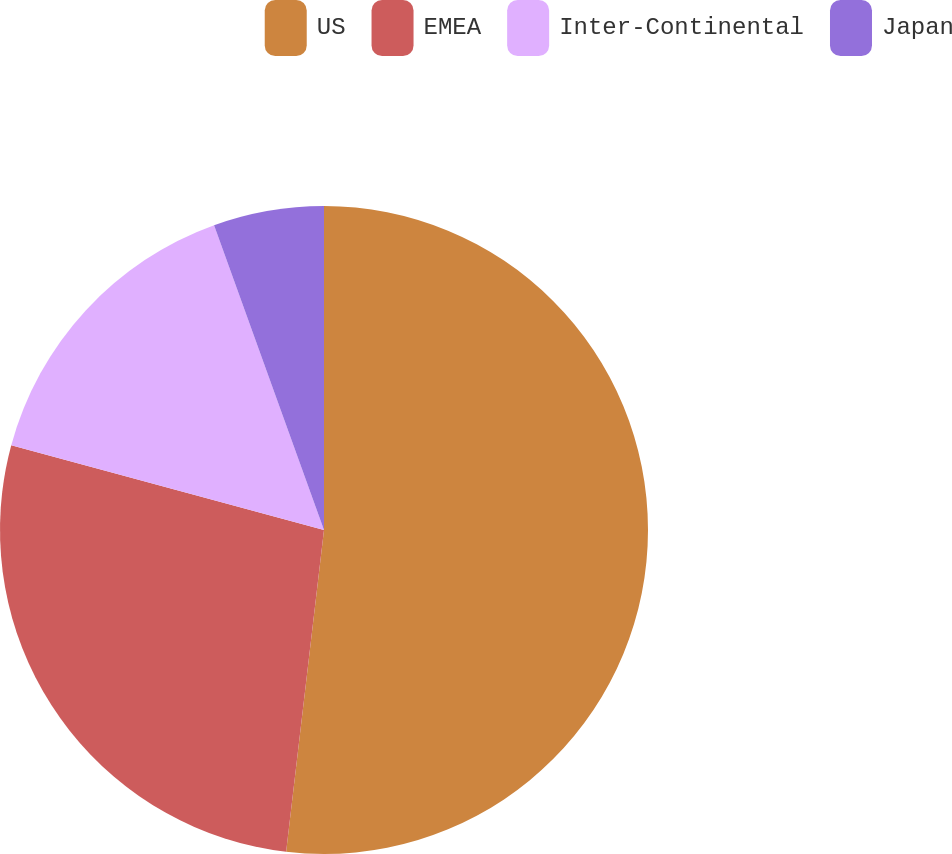<chart> <loc_0><loc_0><loc_500><loc_500><pie_chart><fcel>US<fcel>EMEA<fcel>Inter-Continental<fcel>Japan<nl><fcel>51.87%<fcel>27.35%<fcel>15.28%<fcel>5.51%<nl></chart> 